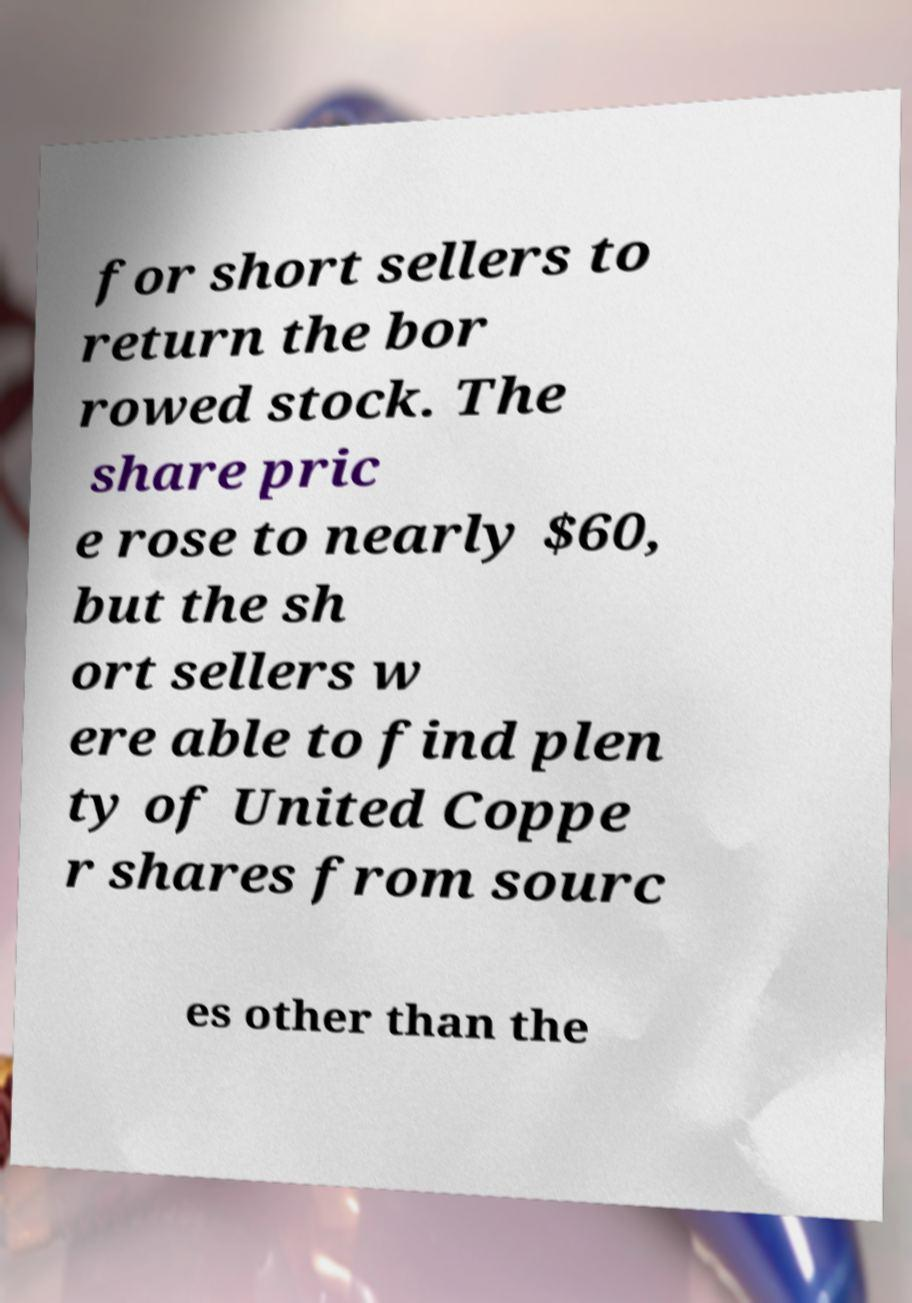Could you assist in decoding the text presented in this image and type it out clearly? for short sellers to return the bor rowed stock. The share pric e rose to nearly $60, but the sh ort sellers w ere able to find plen ty of United Coppe r shares from sourc es other than the 